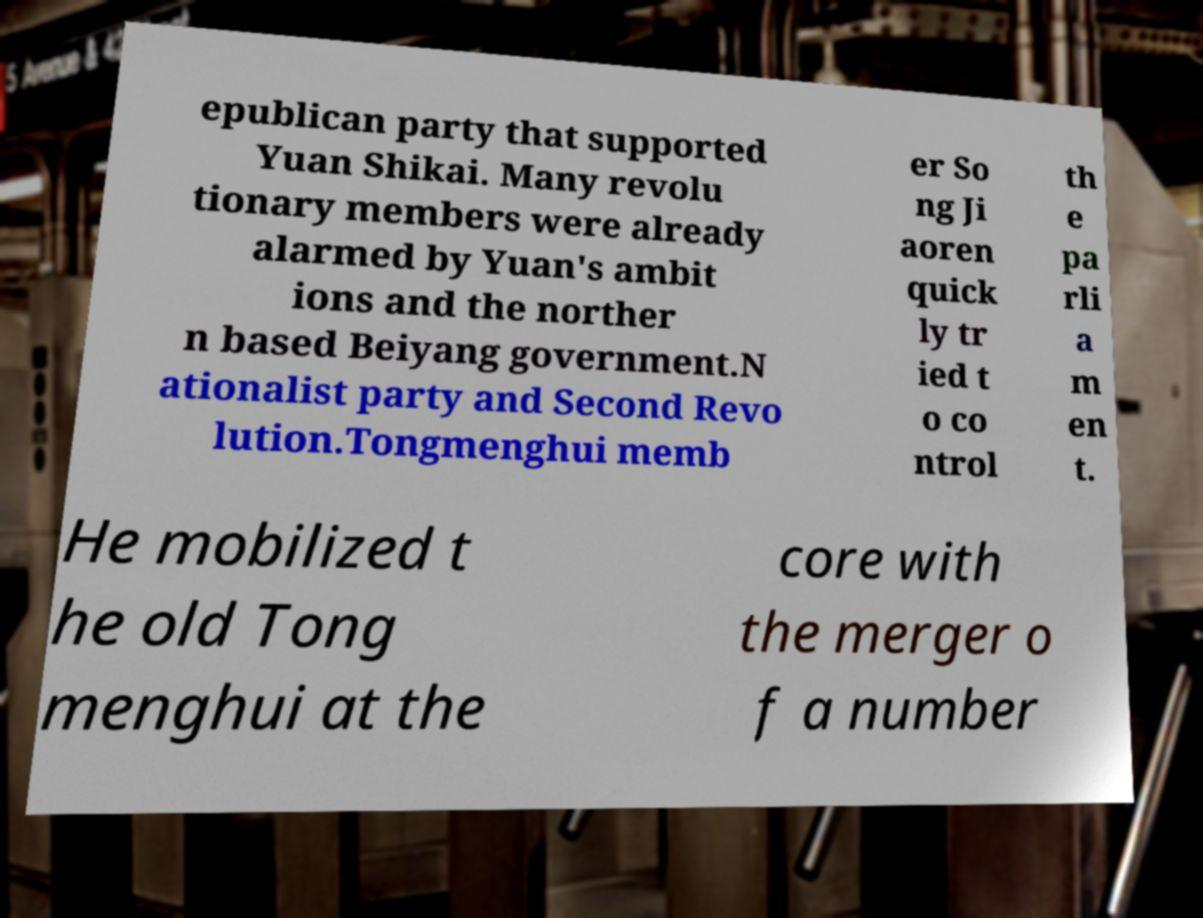Please identify and transcribe the text found in this image. epublican party that supported Yuan Shikai. Many revolu tionary members were already alarmed by Yuan's ambit ions and the norther n based Beiyang government.N ationalist party and Second Revo lution.Tongmenghui memb er So ng Ji aoren quick ly tr ied t o co ntrol th e pa rli a m en t. He mobilized t he old Tong menghui at the core with the merger o f a number 